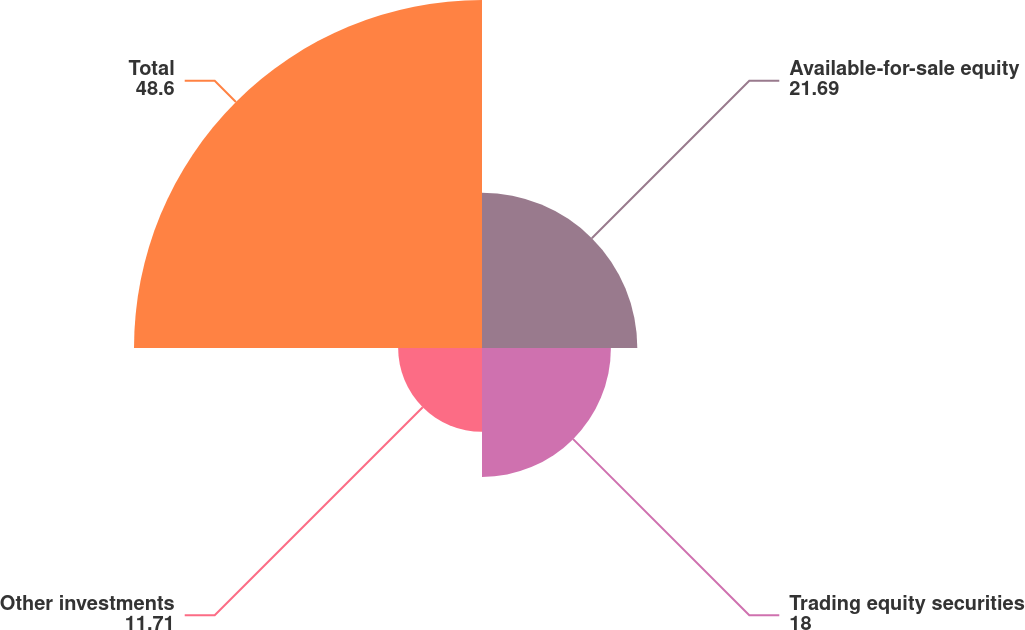<chart> <loc_0><loc_0><loc_500><loc_500><pie_chart><fcel>Available-for-sale equity<fcel>Trading equity securities<fcel>Other investments<fcel>Total<nl><fcel>21.69%<fcel>18.0%<fcel>11.71%<fcel>48.6%<nl></chart> 